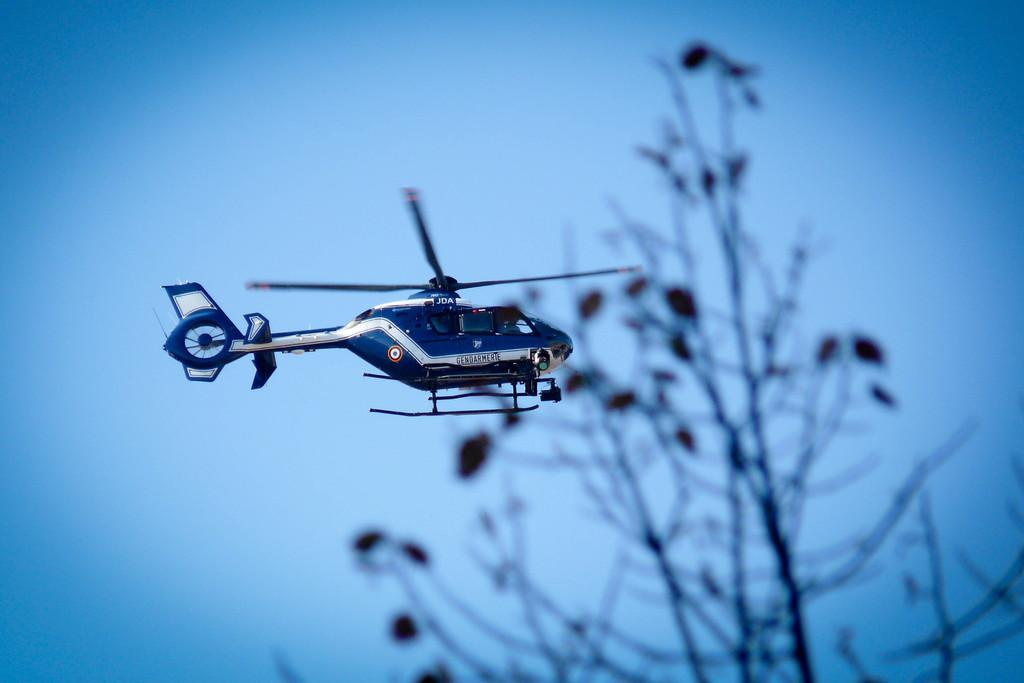What is flying in the air in the image? There is a helicopter flying in the air in the image. What is located beside the helicopter? There is a tree beside the helicopter. What type of shade does the jar provide in the image? There is no jar present in the image, so it cannot provide any shade. 